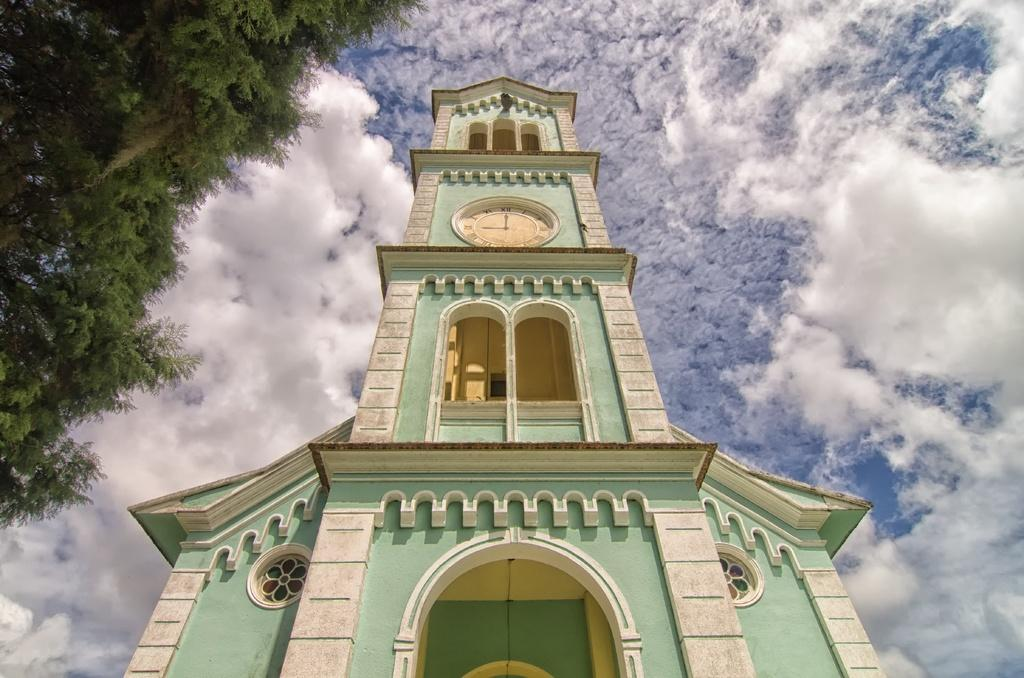What is the main structure in the picture? There is a building in the picture. What features can be observed on the building? The building has windows and a clock with a dial. Can you describe the clock on the building? The clock has a minute hand and an hour hand. What is visible on the left side of the picture? There is a tree on the left side of the picture. How would you describe the sky in the picture? The sky is clear in the picture. How much tax is being paid by the building in the image? There is no information about taxes in the image; it only shows a building with a clock and a tree. Can you hear the duck crying in the image? There are no ducks or sounds mentioned in the image; it only shows a building with a clock and a tree. 